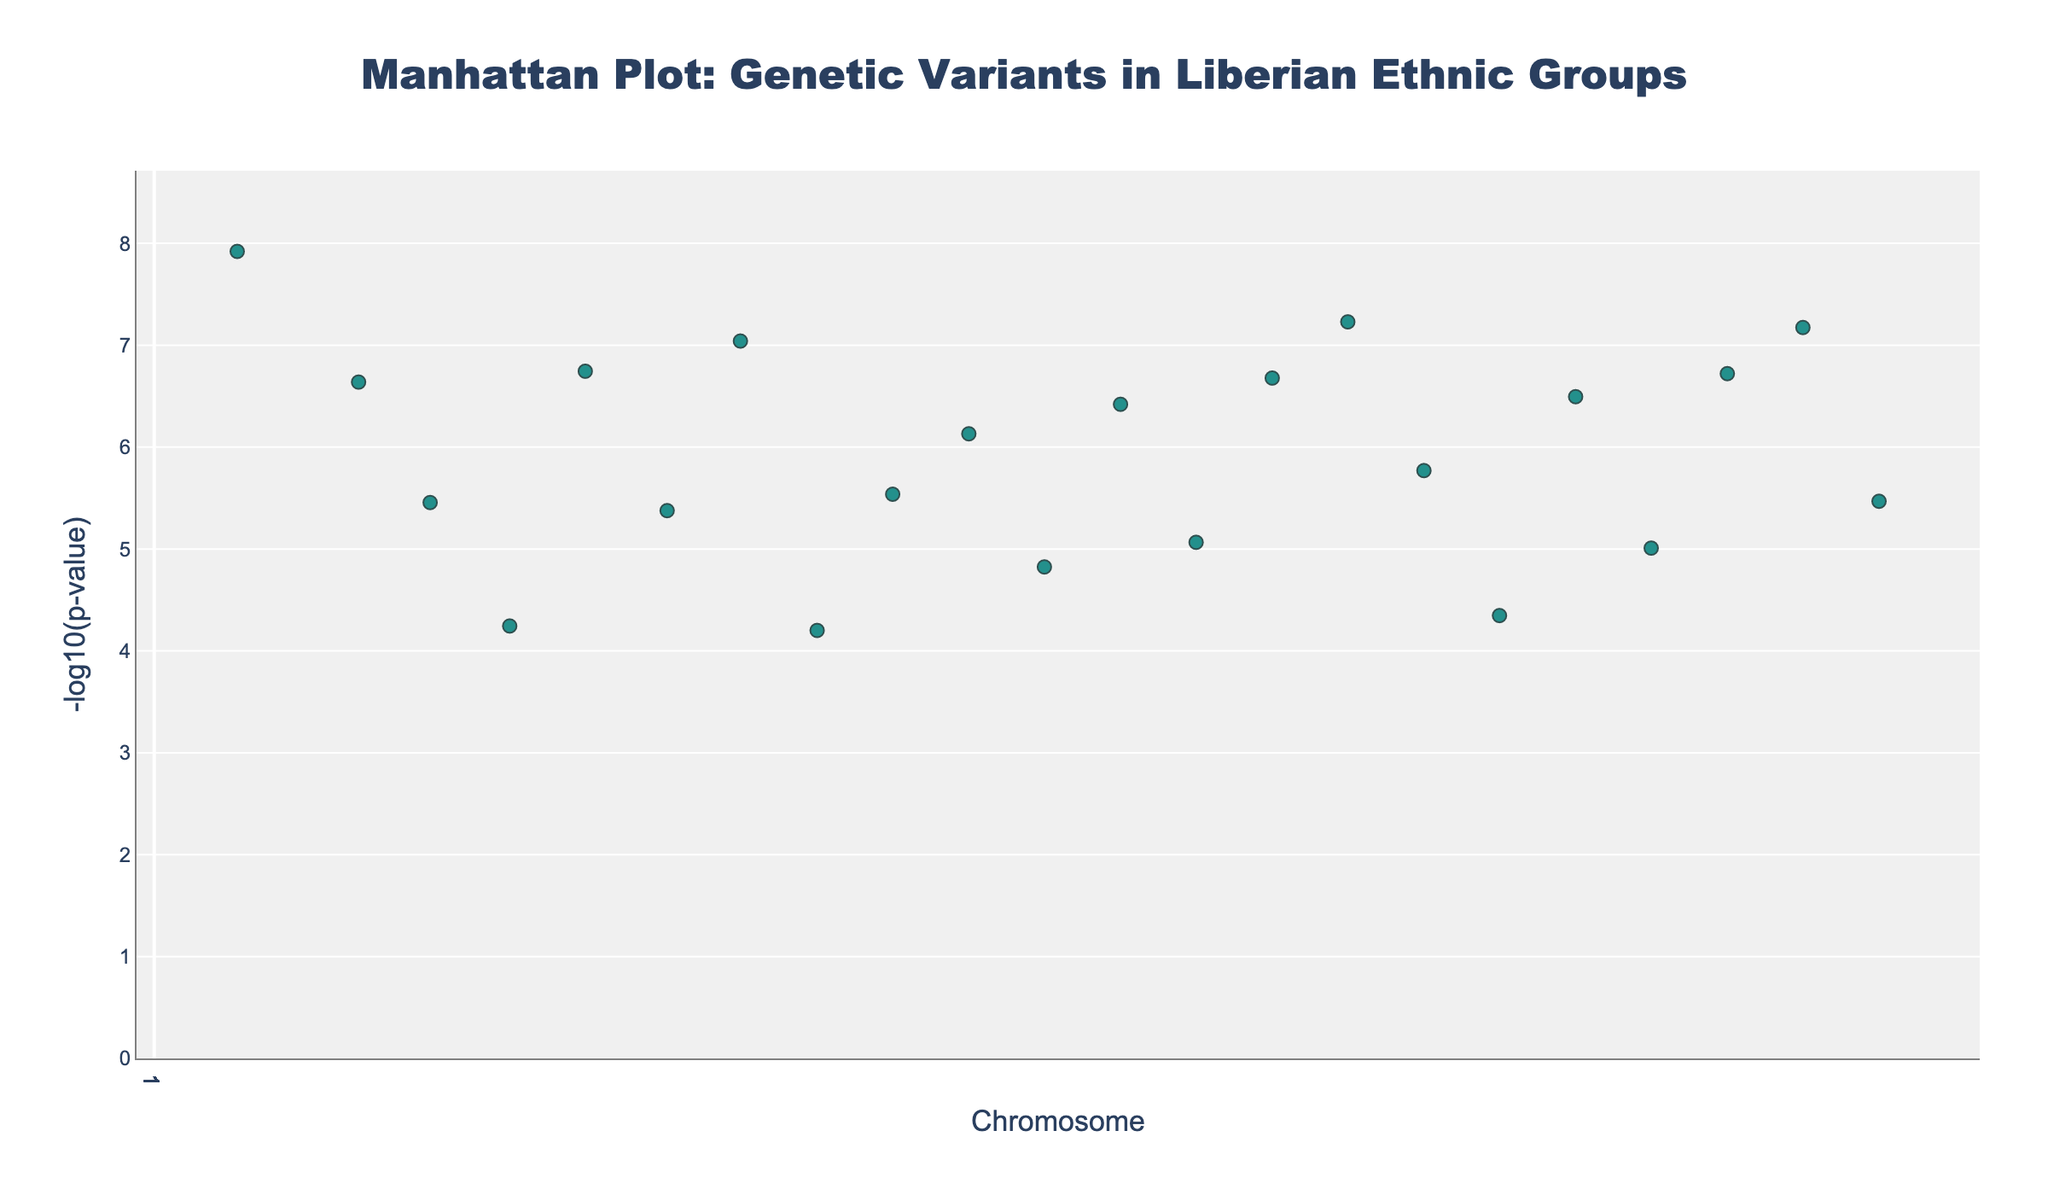What is the title of the plot? The title is usually displayed at the top of the plot. In this case, it reads "Manhattan Plot: Genetic Variants in Liberian Ethnic Groups".
Answer: Manhattan Plot: Genetic Variants in Liberian Ethnic Groups Which chromosome has the SNP with the lowest p-value? The lowest p-value corresponds to the highest -log10(p-value). Chromosome 1 has a significant SNP (rs2814778) with a p-value of 1.2e-8, giving it the highest -log10(p-value) value.
Answer: Chromosome 1 Which SNPs appear on multiple chromosomes and what are those chromosomes? We look for SNPs that appear more than once in the list and identify their corresponding chromosomes. SNP rs17822931 appears on chromosomes 6 and 11. SNP rs4988235 appears on chromosomes 4 and 16. SNP rs2827760 appears on chromosomes 5 and 17.
Answer: rs17822931 on chromosomes 6 and 11, rs4988235 on chromosomes 4 and 16, rs2827760 on chromosomes 5 and 17 Which ethnic group is associated with the most significant SNP? The most significant SNP (lowest p-value or highest -log10(p-value)) is rs2814778. This SNP's ethnicity is mentioned in the data as Kpelle.
Answer: Kpelle What is the range of -log10(p-value) displayed in the plot? By analyzing all values of -log10(p) from the data, we see that the maximum value is derived from the smallest p-value 1.2e-8 (-log10(1.2e-8) ≈ 8.92) and the minimum value from the largest p-value 6.3e-5 (-log10(6.3e-5) ≈ 4.20).
Answer: Approximately 4.20 to 8.92 Which two chromosomes have SNPs with similar -log10(p-value) values and what are those values? Comparing -log10(p-values), chromosomes 3 and 12 have SNPs (rs11720139 and rs12913832, respectively) with close -log10(p-values of 5.46 and 6.42.
Answer: Chromosomes 3 and 12 Which chromosome shows the highest number of significant SNPs? From the data, no single chromosome stands out with multiple significant SNPs. Every chromosome appears to have unique SNPs without repetition per chromosome.
Answer: No specific chromosome 